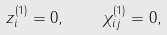Convert formula to latex. <formula><loc_0><loc_0><loc_500><loc_500>z _ { i } ^ { ( 1 ) } = 0 , \quad \chi ^ { ( 1 ) } _ { i j } = 0 ,</formula> 